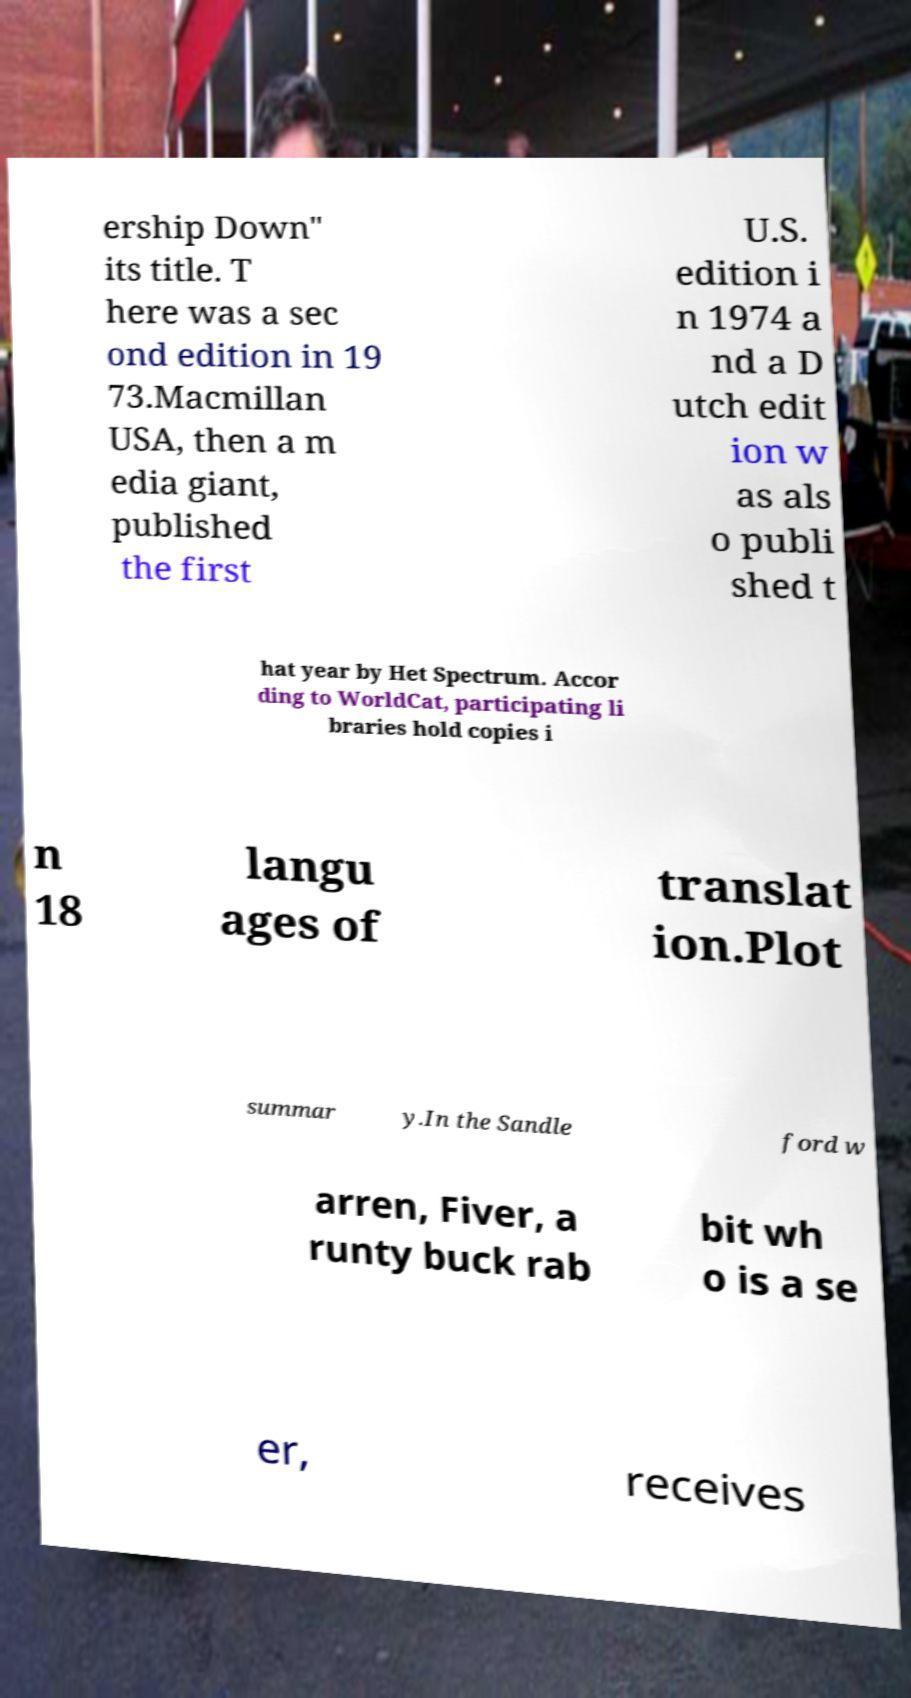For documentation purposes, I need the text within this image transcribed. Could you provide that? ership Down" its title. T here was a sec ond edition in 19 73.Macmillan USA, then a m edia giant, published the first U.S. edition i n 1974 a nd a D utch edit ion w as als o publi shed t hat year by Het Spectrum. Accor ding to WorldCat, participating li braries hold copies i n 18 langu ages of translat ion.Plot summar y.In the Sandle ford w arren, Fiver, a runty buck rab bit wh o is a se er, receives 